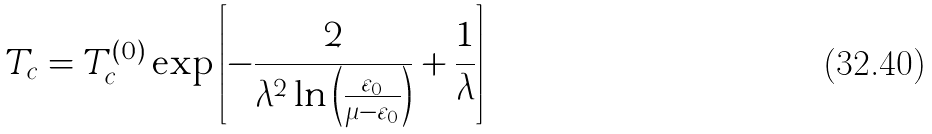Convert formula to latex. <formula><loc_0><loc_0><loc_500><loc_500>T _ { c } = T _ { c } ^ { ( 0 ) } \exp \left [ - \frac { 2 } { \lambda ^ { 2 } \ln \left ( \frac { \varepsilon _ { 0 } } { \mu - \varepsilon _ { 0 } } \right ) } + \frac { 1 } { \lambda } \right ]</formula> 